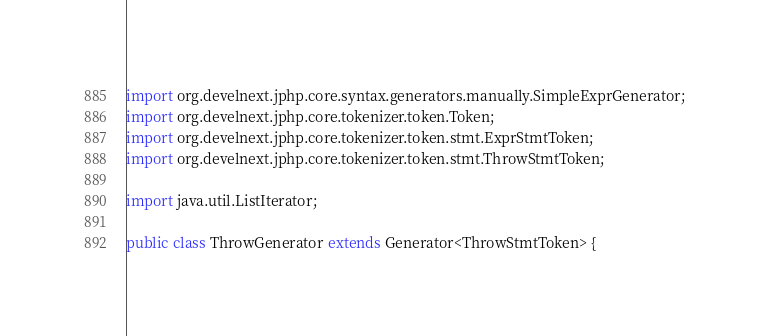Convert code to text. <code><loc_0><loc_0><loc_500><loc_500><_Java_>import org.develnext.jphp.core.syntax.generators.manually.SimpleExprGenerator;
import org.develnext.jphp.core.tokenizer.token.Token;
import org.develnext.jphp.core.tokenizer.token.stmt.ExprStmtToken;
import org.develnext.jphp.core.tokenizer.token.stmt.ThrowStmtToken;

import java.util.ListIterator;

public class ThrowGenerator extends Generator<ThrowStmtToken> {
</code> 